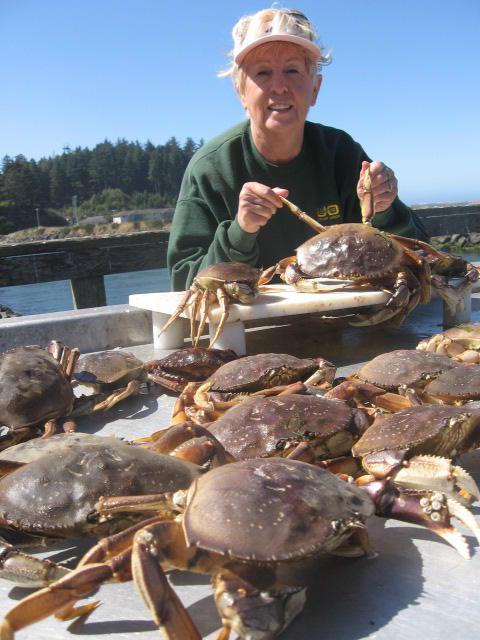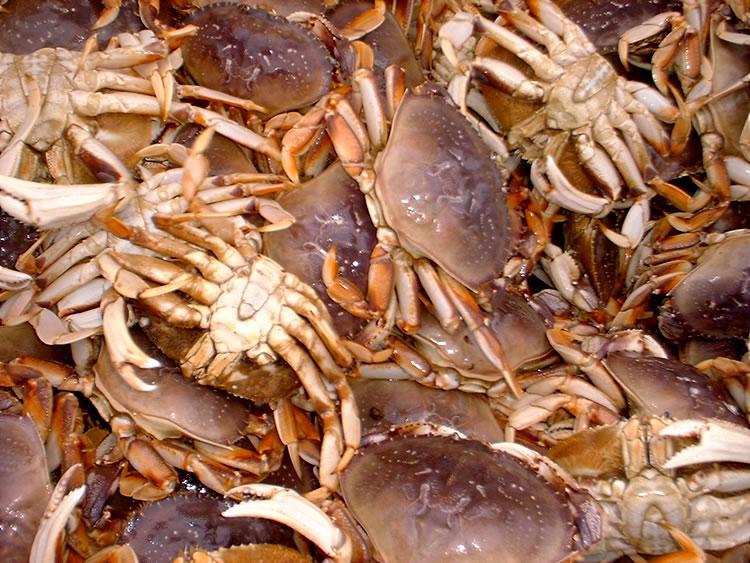The first image is the image on the left, the second image is the image on the right. Evaluate the accuracy of this statement regarding the images: "The crabs in the left image are mostly brown in color; they are not tinted red.". Is it true? Answer yes or no. Yes. The first image is the image on the left, the second image is the image on the right. Analyze the images presented: Is the assertion "The right image shows crabs in a deep container, and the left image shows reddish-orange rightside-up crabs in a pile." valid? Answer yes or no. No. 